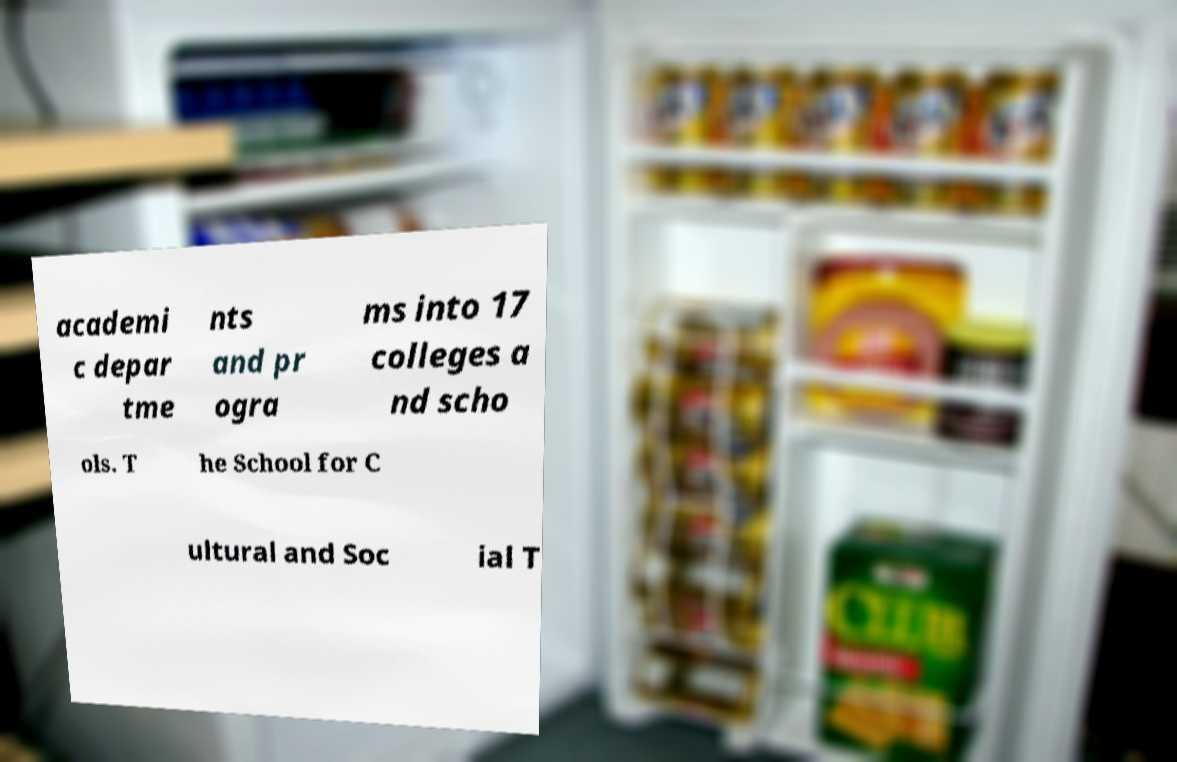There's text embedded in this image that I need extracted. Can you transcribe it verbatim? academi c depar tme nts and pr ogra ms into 17 colleges a nd scho ols. T he School for C ultural and Soc ial T 